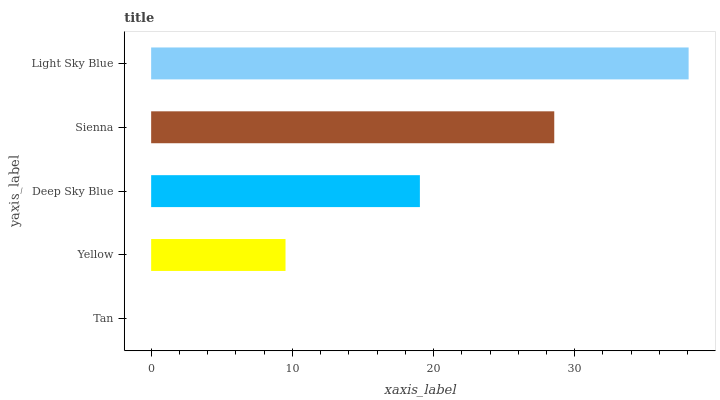Is Tan the minimum?
Answer yes or no. Yes. Is Light Sky Blue the maximum?
Answer yes or no. Yes. Is Yellow the minimum?
Answer yes or no. No. Is Yellow the maximum?
Answer yes or no. No. Is Yellow greater than Tan?
Answer yes or no. Yes. Is Tan less than Yellow?
Answer yes or no. Yes. Is Tan greater than Yellow?
Answer yes or no. No. Is Yellow less than Tan?
Answer yes or no. No. Is Deep Sky Blue the high median?
Answer yes or no. Yes. Is Deep Sky Blue the low median?
Answer yes or no. Yes. Is Tan the high median?
Answer yes or no. No. Is Tan the low median?
Answer yes or no. No. 